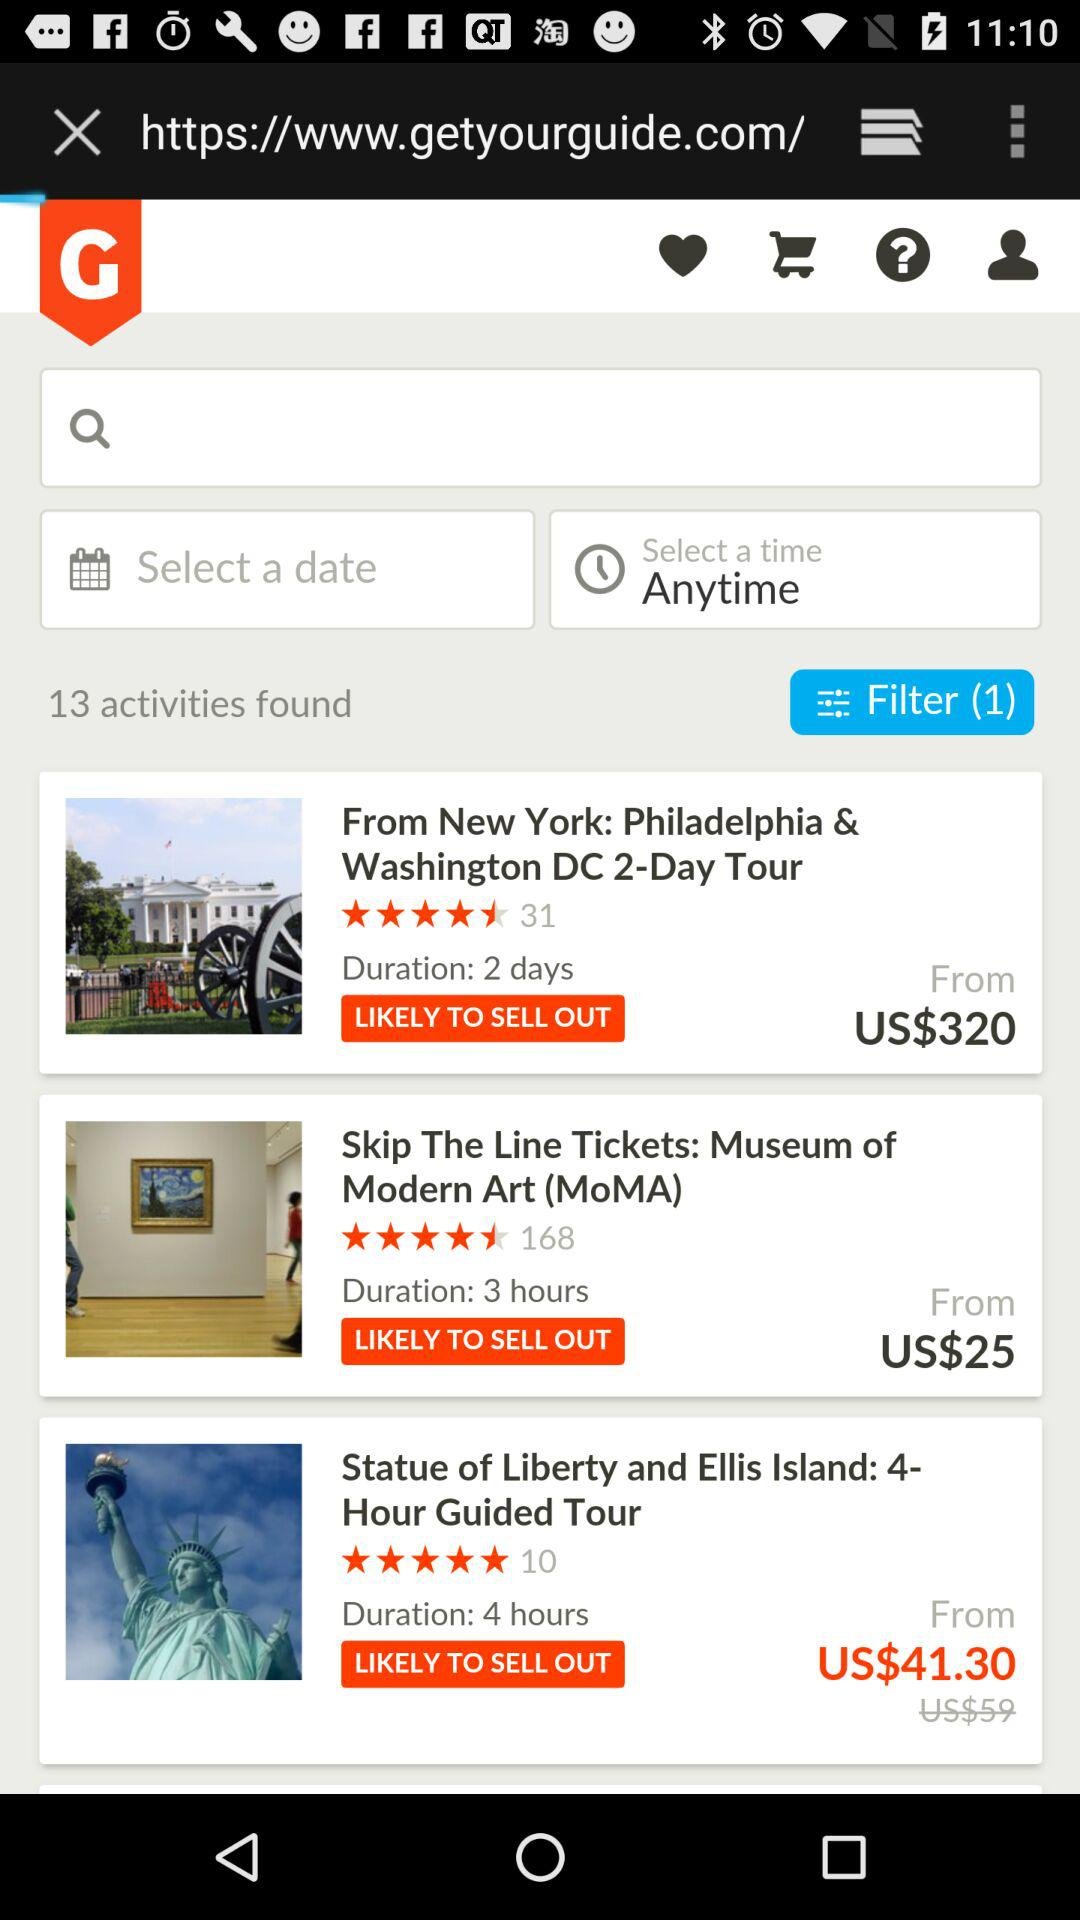What is the tour price of the Museum of Modern Art? The tour price is US$25. 